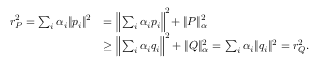<formula> <loc_0><loc_0><loc_500><loc_500>\begin{array} { r l } { r _ { P } ^ { 2 } = \sum _ { i } \alpha _ { i } \| p _ { i } \| ^ { 2 } } & { = \left \| \sum _ { i } \alpha _ { i } p _ { i } \right \| ^ { 2 } \, + \| P \| _ { \alpha } ^ { 2 } } \\ & { \geq \left \| \sum _ { i } \alpha _ { i } q _ { i } \right \| ^ { 2 } + \| Q \| _ { \alpha } ^ { 2 } = \sum _ { i } \alpha _ { i } \| q _ { i } \| ^ { 2 } = r _ { Q } ^ { 2 } . } \end{array}</formula> 